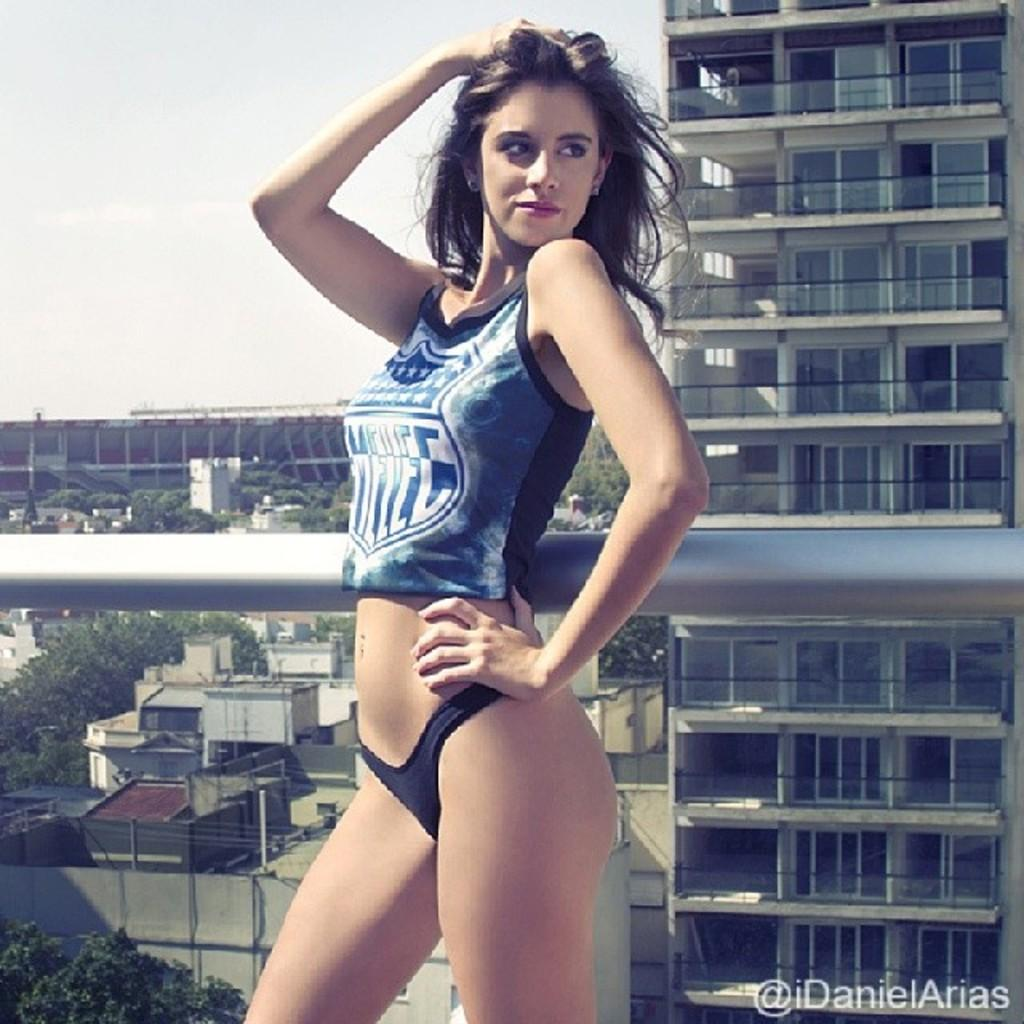Who is present in the image? There is a woman in the image. What is the woman wearing? The woman is wearing a blue dress. What is the woman doing in the image? The woman is standing. What can be seen behind the woman? There is a pole behind the woman. What is visible in the background of the image? There are buildings and trees in the background of the image. What type of waves can be seen crashing on the shore in the image? There are no waves or shore present in the image; it features a woman standing with a pole behind her and buildings and trees in the background. 